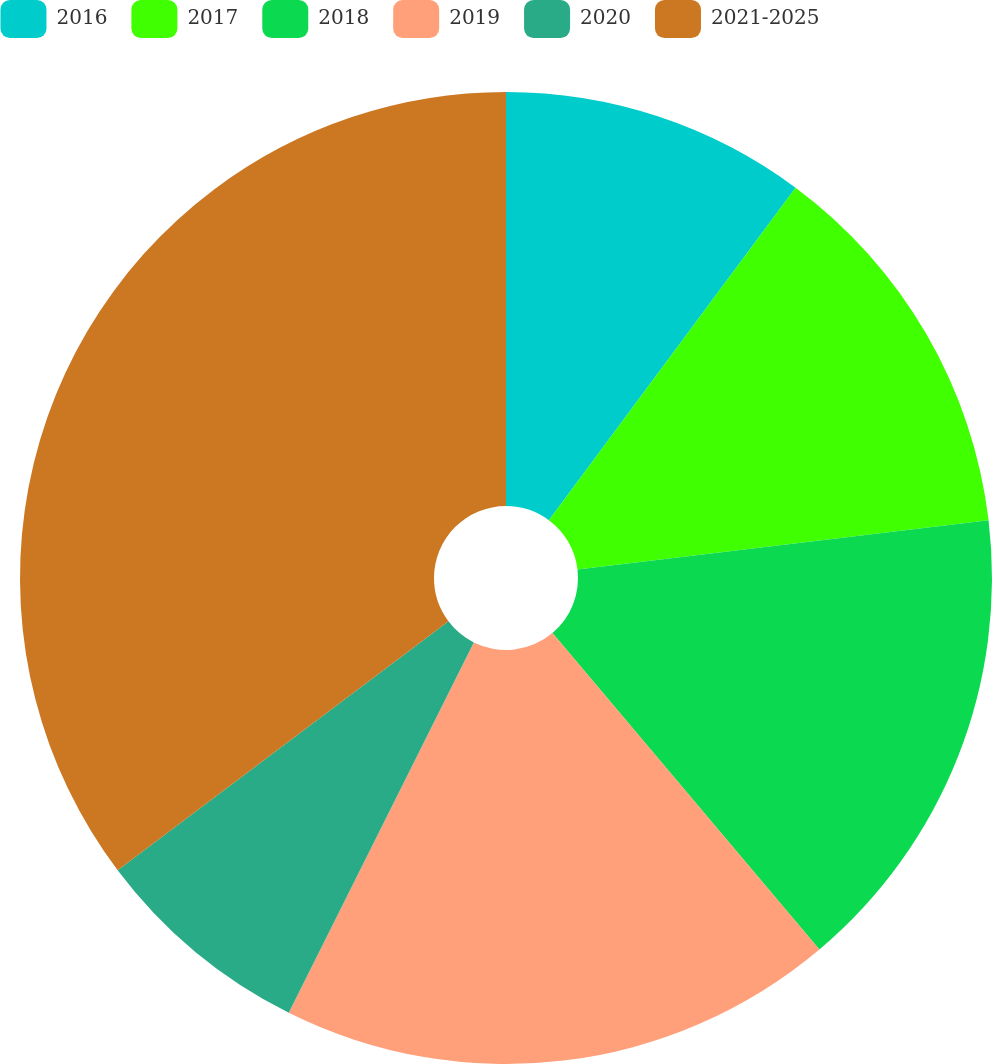<chart> <loc_0><loc_0><loc_500><loc_500><pie_chart><fcel>2016<fcel>2017<fcel>2018<fcel>2019<fcel>2020<fcel>2021-2025<nl><fcel>10.16%<fcel>12.95%<fcel>15.74%<fcel>18.53%<fcel>7.36%<fcel>35.27%<nl></chart> 